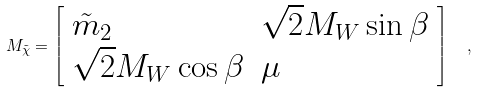<formula> <loc_0><loc_0><loc_500><loc_500>M _ { \tilde { \chi } } = \left [ \begin{array} { l l } { { \tilde { m } _ { 2 } } } & { { \sqrt { 2 } M _ { W } \sin \beta } } \\ { { \sqrt { 2 } M _ { W } \cos \beta } } & { \mu } \end{array} \right ] \ \ ,</formula> 